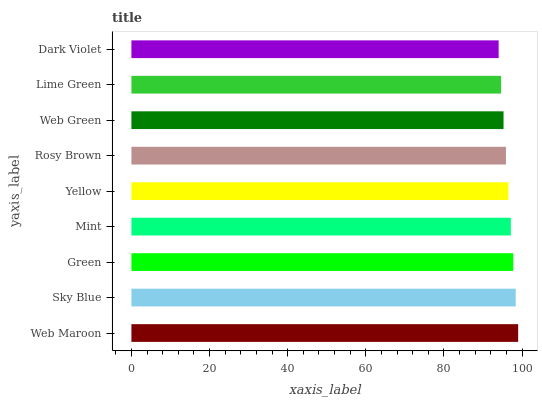Is Dark Violet the minimum?
Answer yes or no. Yes. Is Web Maroon the maximum?
Answer yes or no. Yes. Is Sky Blue the minimum?
Answer yes or no. No. Is Sky Blue the maximum?
Answer yes or no. No. Is Web Maroon greater than Sky Blue?
Answer yes or no. Yes. Is Sky Blue less than Web Maroon?
Answer yes or no. Yes. Is Sky Blue greater than Web Maroon?
Answer yes or no. No. Is Web Maroon less than Sky Blue?
Answer yes or no. No. Is Yellow the high median?
Answer yes or no. Yes. Is Yellow the low median?
Answer yes or no. Yes. Is Web Maroon the high median?
Answer yes or no. No. Is Sky Blue the low median?
Answer yes or no. No. 